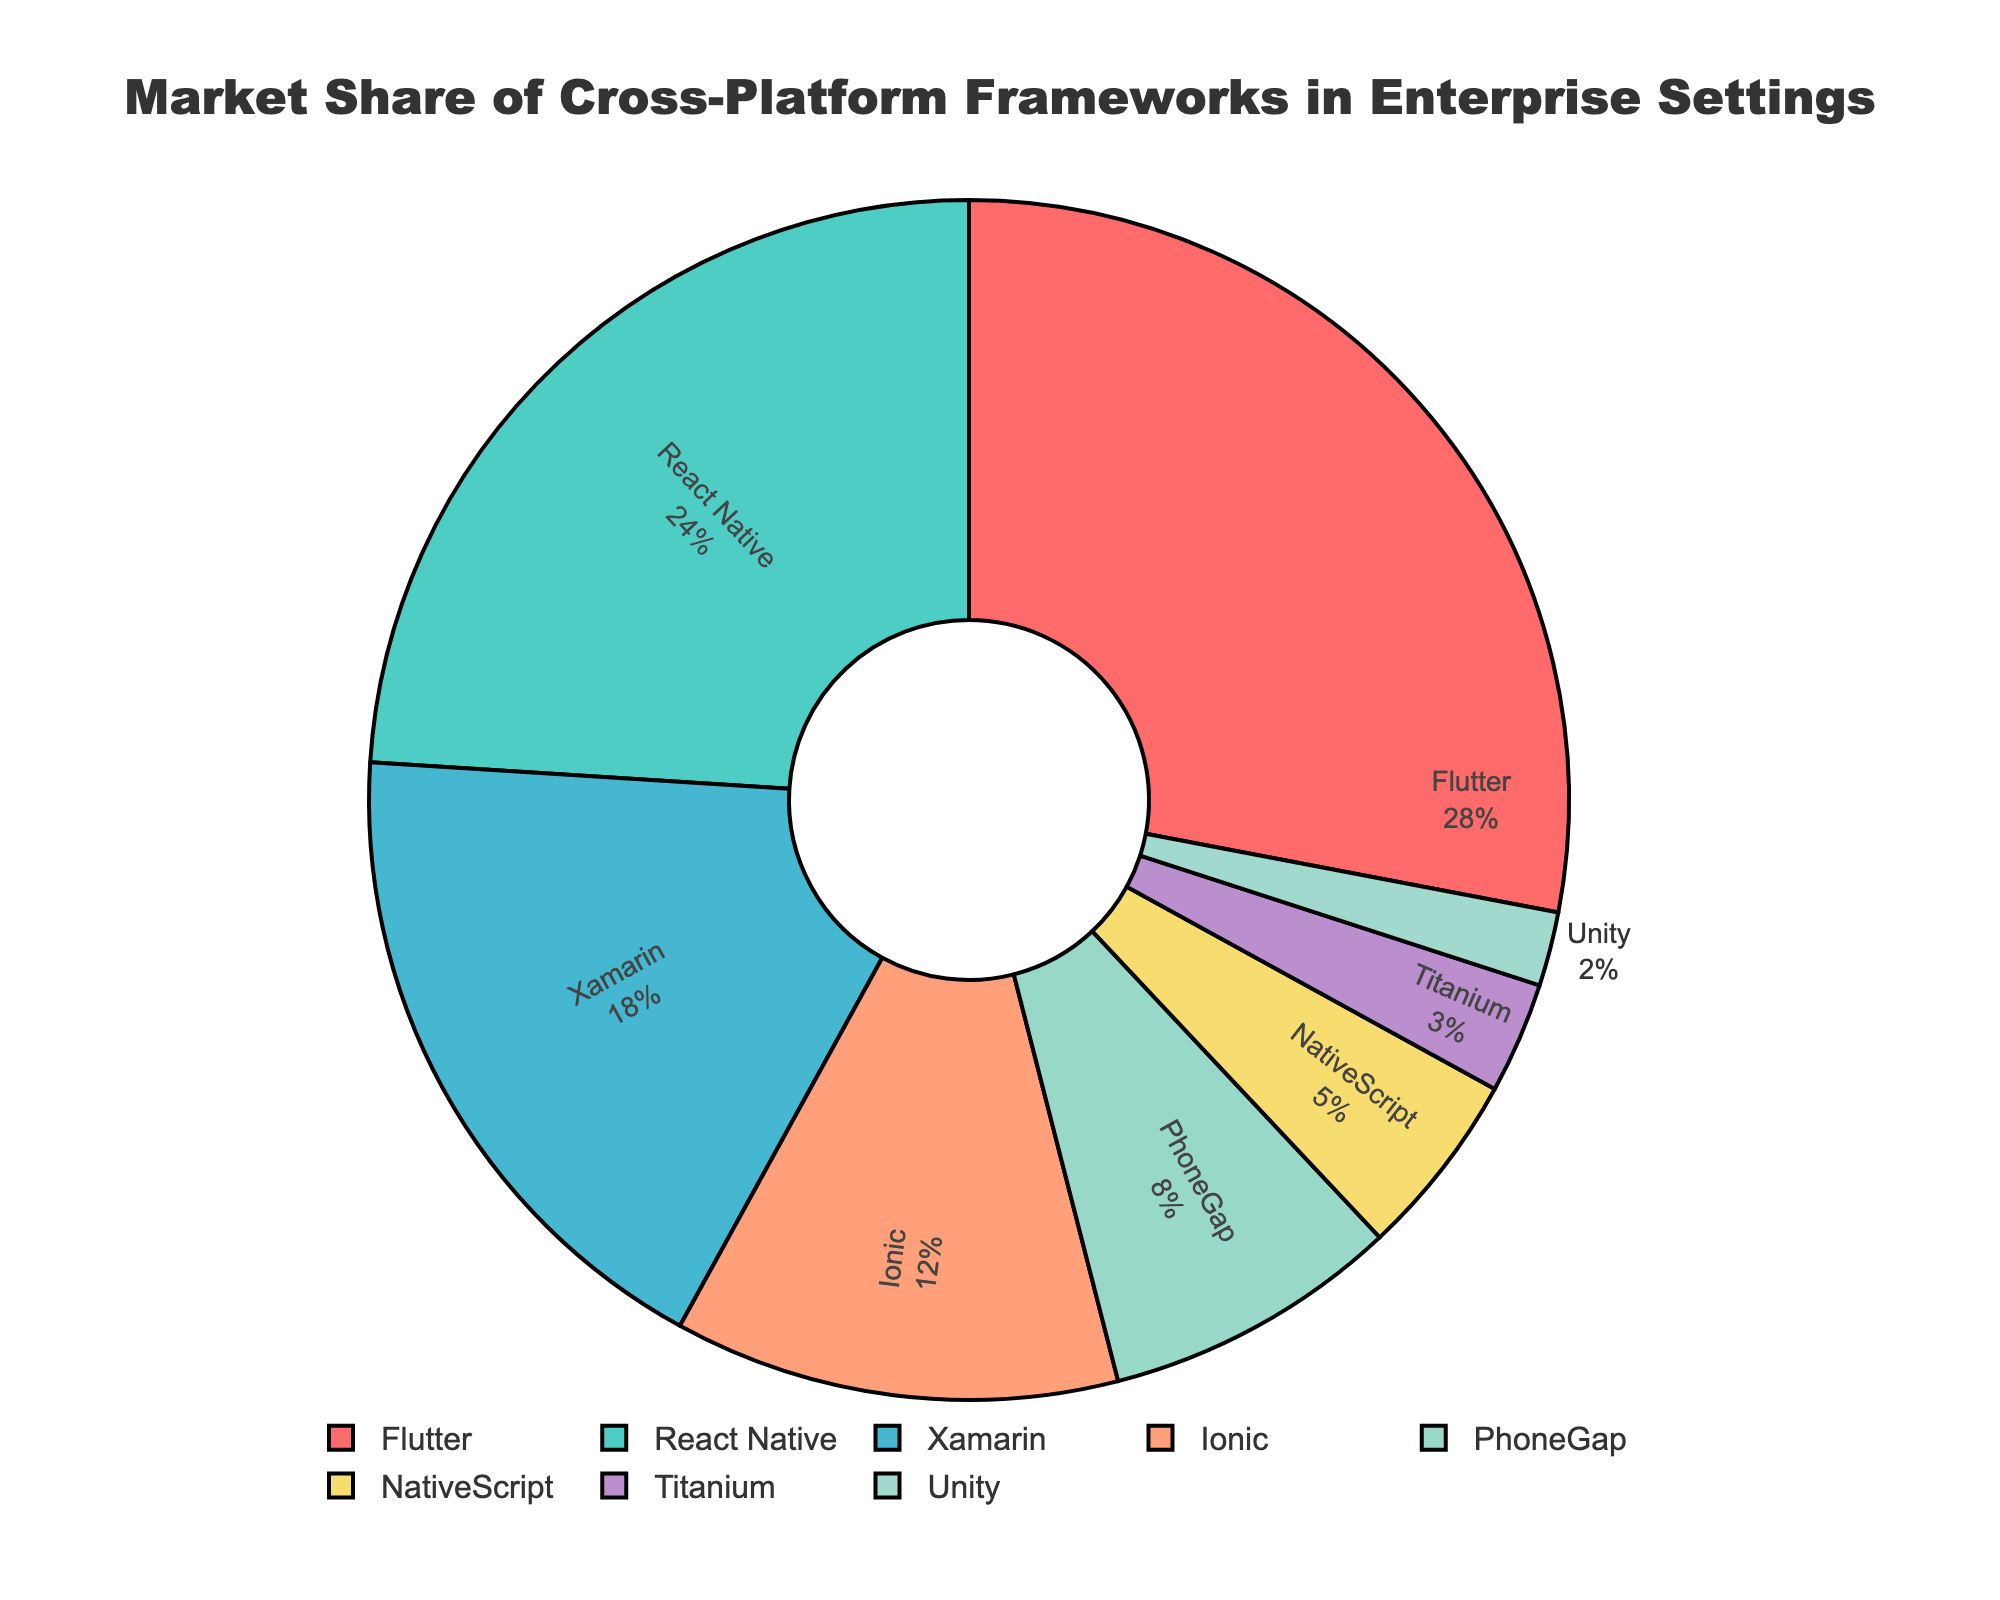What percentage of the market does Flutter hold? Look at the pie chart and find the segment labeled "Flutter". The pie chart shows the label along with the percentage value for each segment.
Answer: 28% How much larger is Flutter's market share compared to Unity's? Identify the segment labeled "Flutter" and note its market share (28%). Then, find the segment labeled "Unity" (2%). Subtract Unity's market share from Flutter's (28% - 2% = 26%).
Answer: 26% Which framework has the second-largest market share? Look at the pie chart and identify the framework with the second-largest segment. According to the pie chart, React Native holds the second-largest segment.
Answer: React Native What is the combined market share of Xamarin and Ionic? Locate the segments labeled "Xamarin" and "Ionic" and note their market shares (18% and 12%, respectively). Add the values together to find the combined market share (18% + 12% = 30%).
Answer: 30% Is PhoneGap's market share more or less than 10%? Look for the segment labeled "PhoneGap" and observe its market share value. According to the chart, PhoneGap's market share is 8%.
Answer: Less What fraction of the total market is controlled by Frameworks with less than 10% market share? Identify frameworks with less than 10% market share: PhoneGap (8%), NativeScript (5%), Titanium (3%), and Unity (2%). Add these percentages (8% + 5% + 3% + 2% = 18%).
Answer: 18% Which color represents NativeScript on the pie chart? Observe the pie chart and locate the segment labeled "NativeScript". Note the color of this segment. NativeScript is represented by a purple color.
Answer: Purple How much smaller is Ionic's market share compared to React Native's? Identify the market shares for Ionic (12%) and React Native (24%). Subtract the smaller value from the larger one (24% - 12% = 12%).
Answer: 12% Which frameworks together make up more than half of the market share? Sum the market shares starting from the largest until the cumulative sum exceeds 50%. Flutter (28%) + React Native (24%) = 52%.
Answer: Flutter and React Native 